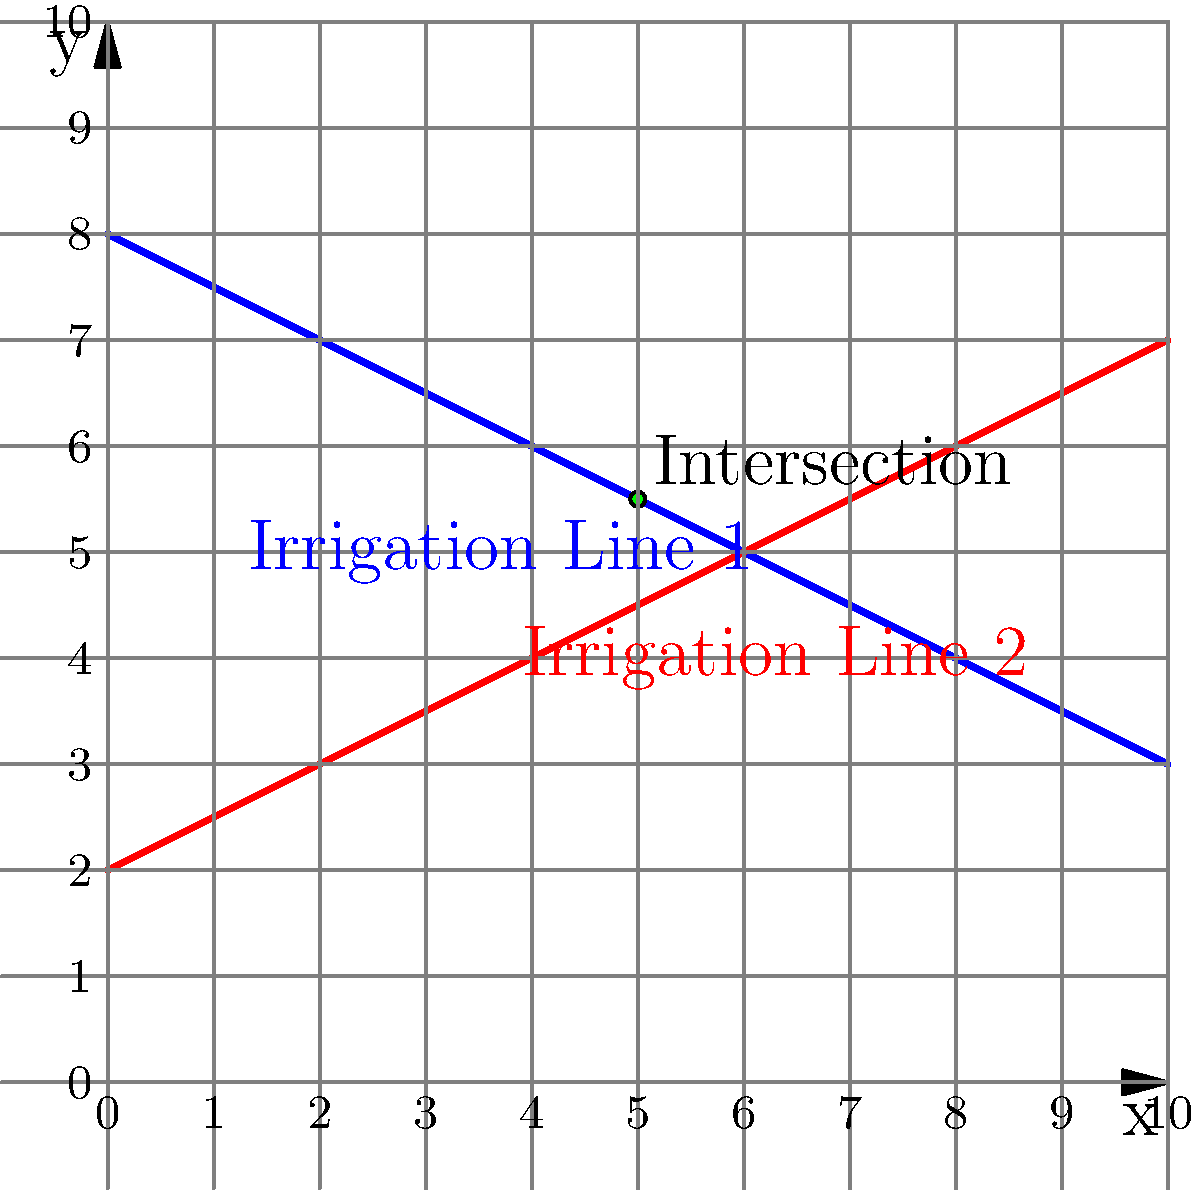As a dairy farmer using sustainable practices, you've implemented an efficient irrigation system. Two irrigation lines are represented by the following equations:

Line 1: $y = -0.5x + 8$
Line 2: $y = 0.5x + 2$

At what point $(x, y)$ do these irrigation lines intersect, and what is the total length of irrigation line needed to reach this intersection point from the y-axis? To solve this problem, we'll follow these steps:

1) Find the intersection point of the two lines:
   At the intersection point, the y-coordinates are equal. So we can set the equations equal to each other:
   $-0.5x + 8 = 0.5x + 2$

2) Solve for x:
   $-0.5x + 8 = 0.5x + 2$
   $8 - 2 = 0.5x + 0.5x$
   $6 = x$

3) Find y by substituting x = 6 into either equation:
   $y = -0.5(6) + 8 = -3 + 8 = 5$

   So, the intersection point is $(6, 5)$

4) Calculate the length of irrigation line from y-axis to intersection point:
   For Line 1: From (0,8) to (6,5)
   For Line 2: From (0,2) to (6,5)

   Use the distance formula: $d = \sqrt{(x_2-x_1)^2 + (y_2-y_1)^2}$

   Line 1: $d_1 = \sqrt{(6-0)^2 + (5-8)^2} = \sqrt{36 + 9} = \sqrt{45} = 3\sqrt{5}$
   Line 2: $d_2 = \sqrt{(6-0)^2 + (5-2)^2} = \sqrt{36 + 9} = \sqrt{45} = 3\sqrt{5}$

5) Total length: $3\sqrt{5} + 3\sqrt{5} = 6\sqrt{5}$
Answer: Intersection point: $(6, 5)$; Total length: $6\sqrt{5}$ units 